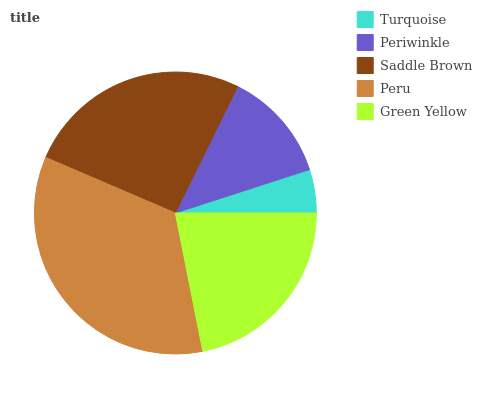Is Turquoise the minimum?
Answer yes or no. Yes. Is Peru the maximum?
Answer yes or no. Yes. Is Periwinkle the minimum?
Answer yes or no. No. Is Periwinkle the maximum?
Answer yes or no. No. Is Periwinkle greater than Turquoise?
Answer yes or no. Yes. Is Turquoise less than Periwinkle?
Answer yes or no. Yes. Is Turquoise greater than Periwinkle?
Answer yes or no. No. Is Periwinkle less than Turquoise?
Answer yes or no. No. Is Green Yellow the high median?
Answer yes or no. Yes. Is Green Yellow the low median?
Answer yes or no. Yes. Is Peru the high median?
Answer yes or no. No. Is Periwinkle the low median?
Answer yes or no. No. 